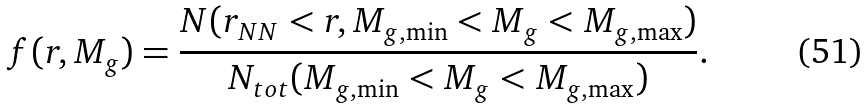<formula> <loc_0><loc_0><loc_500><loc_500>f ( r , M _ { g } ) = \frac { N ( r _ { N N } < r , M _ { g , \min } < M _ { g } < M _ { g , \max } ) } { N _ { t o t } ( M _ { g , \min } < M _ { g } < M _ { g , \max } ) } .</formula> 